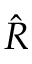Convert formula to latex. <formula><loc_0><loc_0><loc_500><loc_500>\hat { R }</formula> 